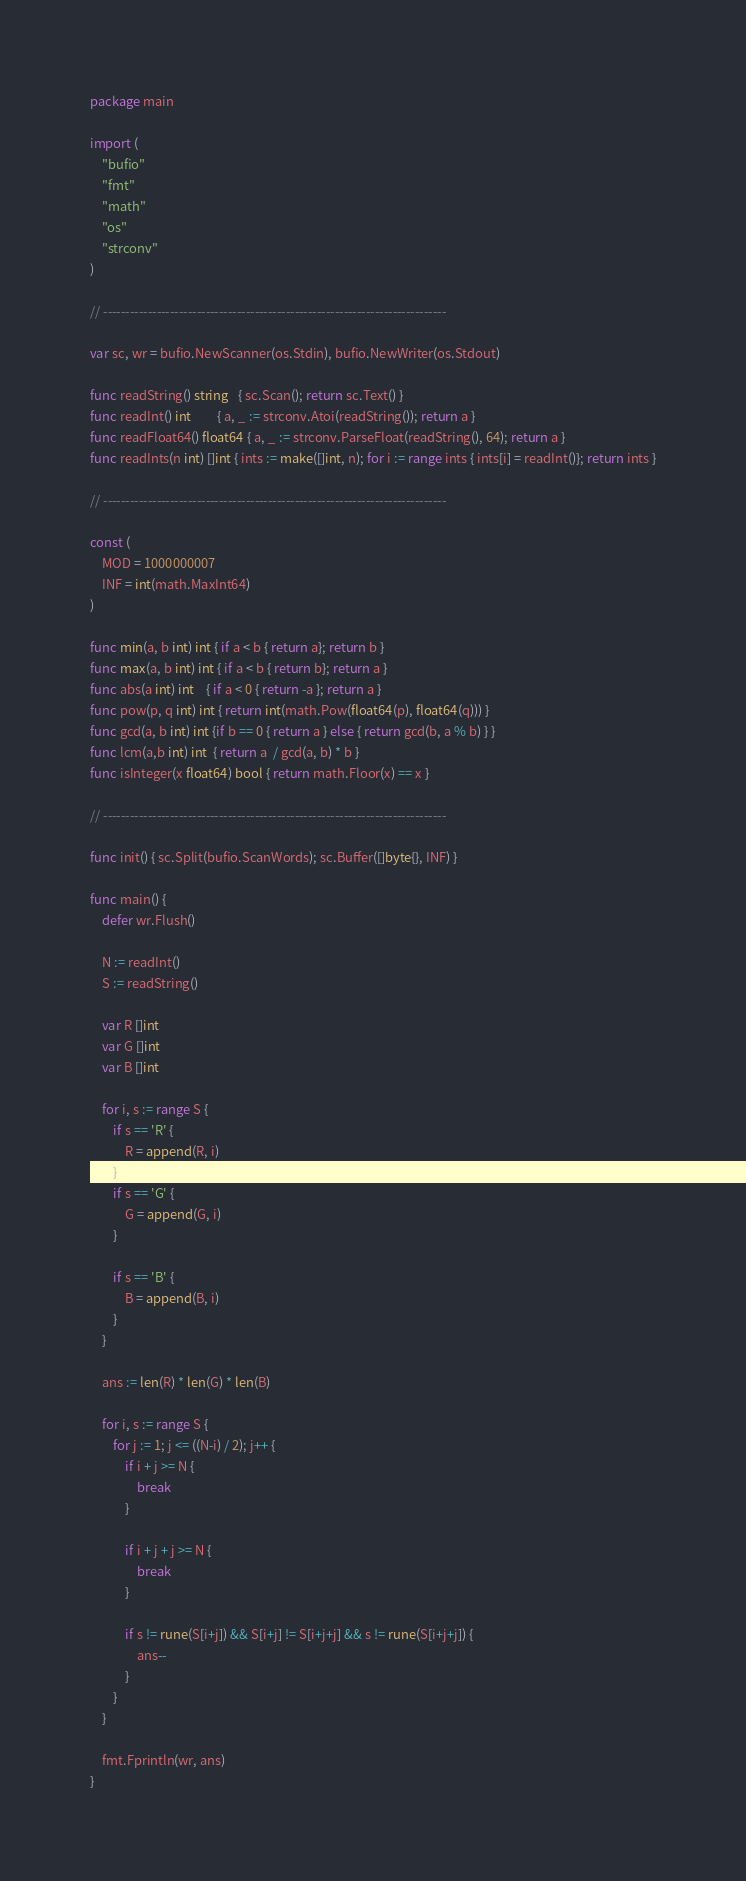Convert code to text. <code><loc_0><loc_0><loc_500><loc_500><_Go_>package main

import (
	"bufio"
	"fmt"
	"math"
	"os"
	"strconv"
)

// -----------------------------------------------------------------------------

var sc, wr = bufio.NewScanner(os.Stdin), bufio.NewWriter(os.Stdout)

func readString() string   { sc.Scan(); return sc.Text() }
func readInt() int         { a, _ := strconv.Atoi(readString()); return a }
func readFloat64() float64 { a, _ := strconv.ParseFloat(readString(), 64); return a }
func readInts(n int) []int { ints := make([]int, n); for i := range ints { ints[i] = readInt()}; return ints }

// -----------------------------------------------------------------------------

const (
	MOD = 1000000007
	INF = int(math.MaxInt64)
)

func min(a, b int) int { if a < b { return a}; return b }
func max(a, b int) int { if a < b { return b}; return a }
func abs(a int) int    { if a < 0 { return -a }; return a }
func pow(p, q int) int { return int(math.Pow(float64(p), float64(q))) }
func gcd(a, b int) int {if b == 0 { return a } else { return gcd(b, a % b) } }
func lcm(a,b int) int  { return a  / gcd(a, b) * b }
func isInteger(x float64) bool { return math.Floor(x) == x }

// -----------------------------------------------------------------------------

func init() { sc.Split(bufio.ScanWords); sc.Buffer([]byte{}, INF) }

func main() {
	defer wr.Flush()

	N := readInt()
	S := readString()

	var R []int
	var G []int
	var B []int

	for i, s := range S {
		if s == 'R' {
			R = append(R, i)
		}
		if s == 'G' {
			G = append(G, i)
		}

		if s == 'B' {
			B = append(B, i)
		}
	}

	ans := len(R) * len(G) * len(B)

	for i, s := range S {
		for j := 1; j <= ((N-i) / 2); j++ {
			if i + j >= N {
				break
			}

			if i + j + j >= N {
				break
			}

			if s != rune(S[i+j]) && S[i+j] != S[i+j+j] && s != rune(S[i+j+j]) {
				ans--
			}
		}
	}

	fmt.Fprintln(wr, ans)
}
</code> 